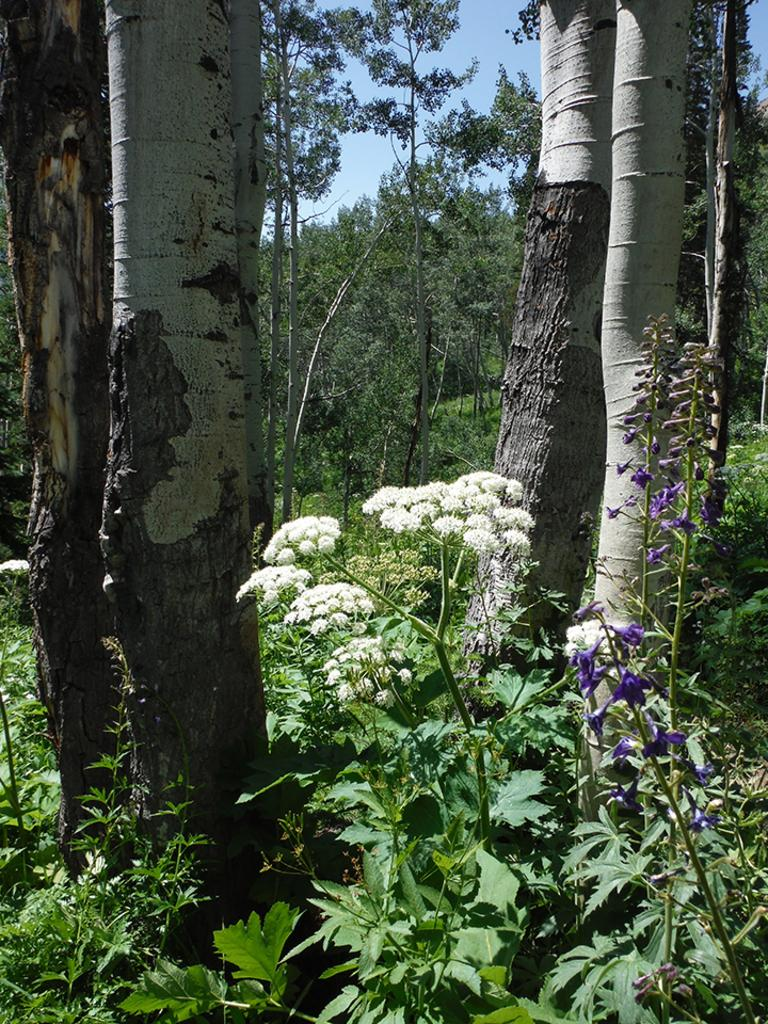What type of plants can be seen in the image? There are plants with flowers in the image. What other vegetation is present in the image? There are trees in the image. What can be seen in the background of the image? The sky is visible in the background of the image. What type of yarn is being used to create the flowers in the image? There is no yarn present in the image; the flowers are natural flowers on plants. What activity is taking place during the recess in the image? There is no recess or any indication of an activity taking place in the image. 